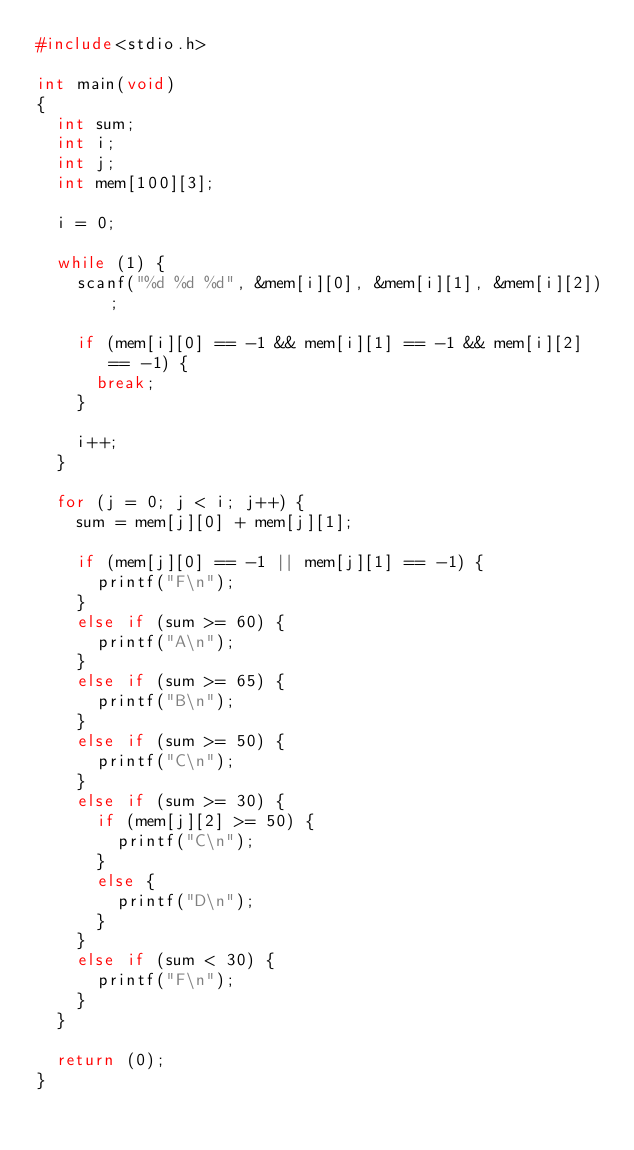<code> <loc_0><loc_0><loc_500><loc_500><_C_>#include<stdio.h>

int main(void)
{
	int sum;
	int i;
	int j;
	int mem[100][3];
	
	i = 0;
	
	while (1) {
		scanf("%d %d %d", &mem[i][0], &mem[i][1], &mem[i][2]);
		
		if (mem[i][0] == -1 && mem[i][1] == -1 && mem[i][2] == -1) {
			break;
		}
		
		i++;
	}
	
	for (j = 0; j < i; j++) {
		sum = mem[j][0] + mem[j][1];
		
		if (mem[j][0] == -1 || mem[j][1] == -1) {
			printf("F\n");
		}
		else if (sum >= 60) {
			printf("A\n");
		}
		else if (sum >= 65) {
			printf("B\n");
		}
		else if (sum >= 50) {
			printf("C\n");
		}
		else if (sum >= 30) {
			if (mem[j][2] >= 50) {
				printf("C\n");
			}
			else {
				printf("D\n");
			}
		}
		else if (sum < 30) {
			printf("F\n");
		}
	}
	
	return (0);
}</code> 